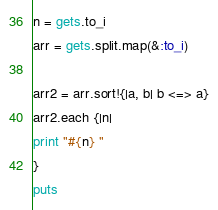Convert code to text. <code><loc_0><loc_0><loc_500><loc_500><_Ruby_>n = gets.to_i
arr = gets.split.map(&:to_i)

arr2 = arr.sort!{|a, b| b <=> a}
arr2.each {|n|
print "#{n} "
}
puts</code> 